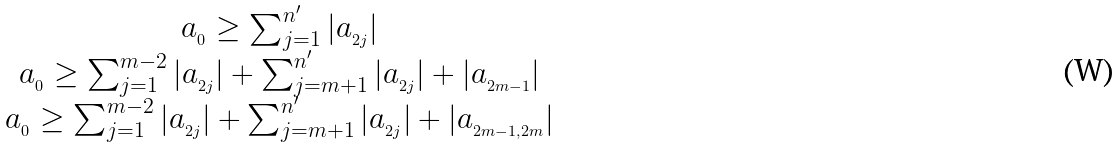<formula> <loc_0><loc_0><loc_500><loc_500>\begin{array} { c } a _ { _ { 0 } } \geq \sum _ { j = 1 } ^ { n ^ { \prime } } | a _ { _ { 2 j } } | \\ a _ { _ { 0 } } \geq \sum _ { j = 1 } ^ { m - 2 } | a _ { _ { 2 j } } | + \sum _ { j = m + 1 } ^ { n ^ { \prime } } | a _ { _ { 2 j } } | + | a _ { _ { 2 m - 1 } } | \\ a _ { _ { 0 } } \geq \sum _ { j = 1 } ^ { m - 2 } | a _ { _ { 2 j } } | + \sum _ { j = m + 1 } ^ { n ^ { \prime } } | a _ { _ { 2 j } } | + | a _ { _ { 2 m - 1 , 2 m } } | \\ \end{array}</formula> 